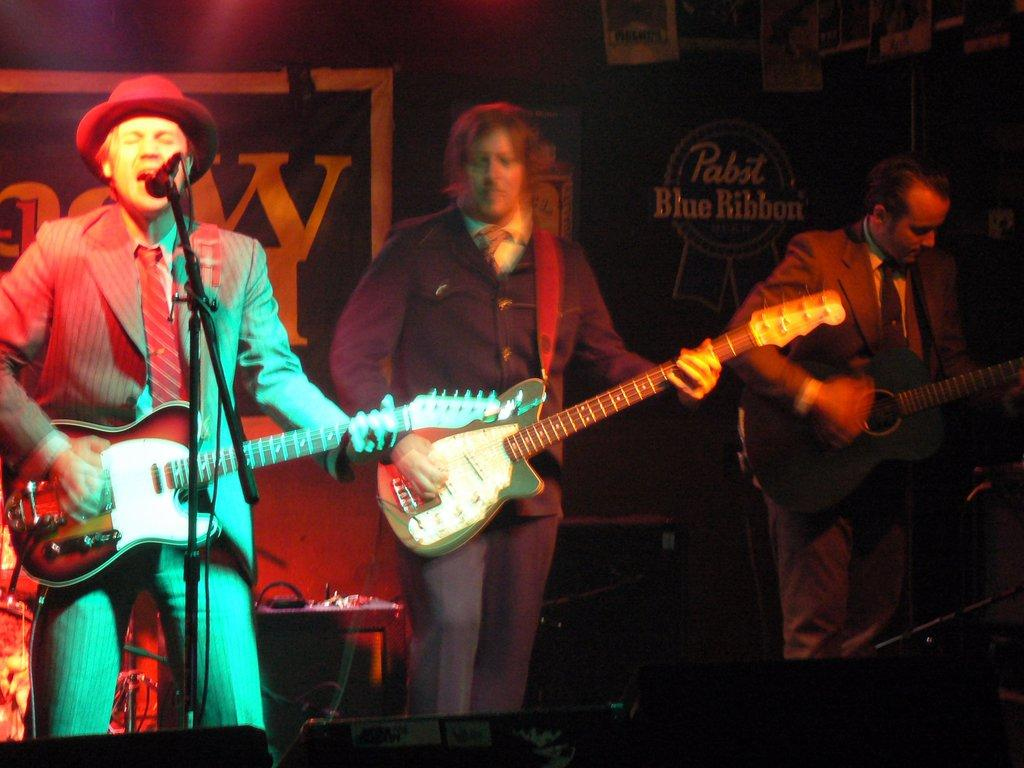What are the three men in the image doing? The three men are playing guitars in the image. Is there any vocal accompaniment to the guitar playing? Yes, one man is singing on a microphone. What can be seen in the background of the image? There is a wall with banners and a table in the background. Can you tell me how many bananas are on the table in the image? There is no mention of bananas in the image; the table is described as being in the background, but no specific items are mentioned. 